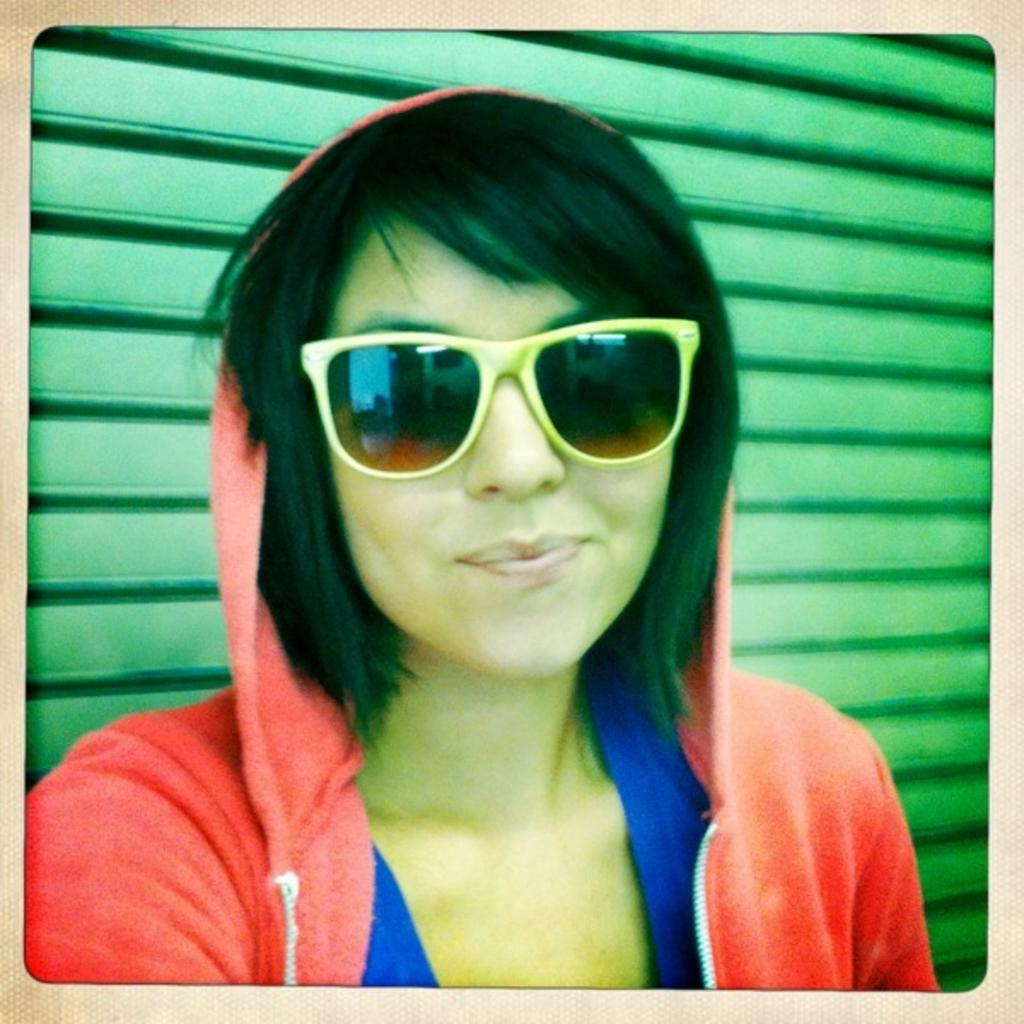What is the main subject of the image? There is a person in the image. What type of protective eyewear is the person wearing? The person is wearing goggles. What type of clothing is the person wearing on their upper body? The person is wearing a hoodie. Can you describe any architectural features in the image? Yes, there is a green shutter in the image. What type of chalk is the person using to draw on the wall in the image? There is no chalk or drawing on the wall present in the image. What time of day is it in the image, considering the person's attire? The time of day cannot be determined from the person's attire in the image. --- Facts: 1. There is a person in the image. 2. The person is holding a guitar. 3. The person is standing on a stage. 4. There are speakers on the stage. 5. There is a microphone on a stand. Absurd Topics: snow, sandcastle, bicycle Conversation: What is the main subject of the image? There is a person in the image. What is the person holding in the image? The person is holding a guitar. Where is the person located in the image? The person is standing on a stage. What type of equipment is present on the stage? There are speakers on the stage, and there is a microphone on a stand. Reasoning: Let's think step by step in order to produce the conversation. We start by identifying the main subject of the image, which is the person. Then, we describe specific features of the person, such as the guitar they are holding. Next, we observe the location of the person, noting that they are standing on a stage. Finally, we describe the equipment present on the stage, including the speakers and the microphone on a stand. Absurd Question/Answer: What type of snow sculpture can be seen in the image? There is no snow or snow sculpture present in the image. Can you describe the sandcastle that the person is standing next to in the image? There is no sandcastle present in the image. What type of bicycle is the person riding in the image? There is no bicycle present in the image. 